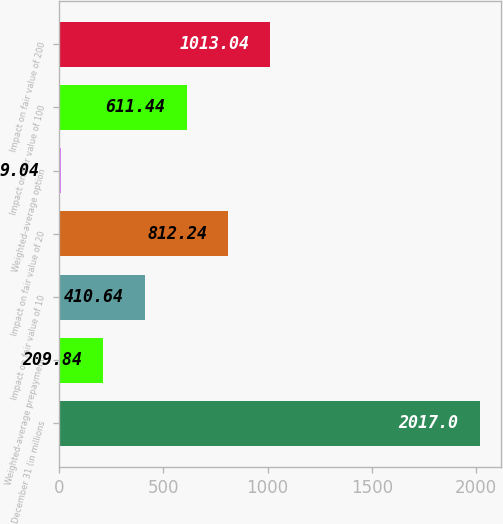Convert chart. <chart><loc_0><loc_0><loc_500><loc_500><bar_chart><fcel>December 31 (in millions<fcel>Weighted-average prepayment<fcel>Impact on fair value of 10<fcel>Impact on fair value of 20<fcel>Weighted-average option<fcel>Impact on fair value of 100<fcel>Impact on fair value of 200<nl><fcel>2017<fcel>209.84<fcel>410.64<fcel>812.24<fcel>9.04<fcel>611.44<fcel>1013.04<nl></chart> 